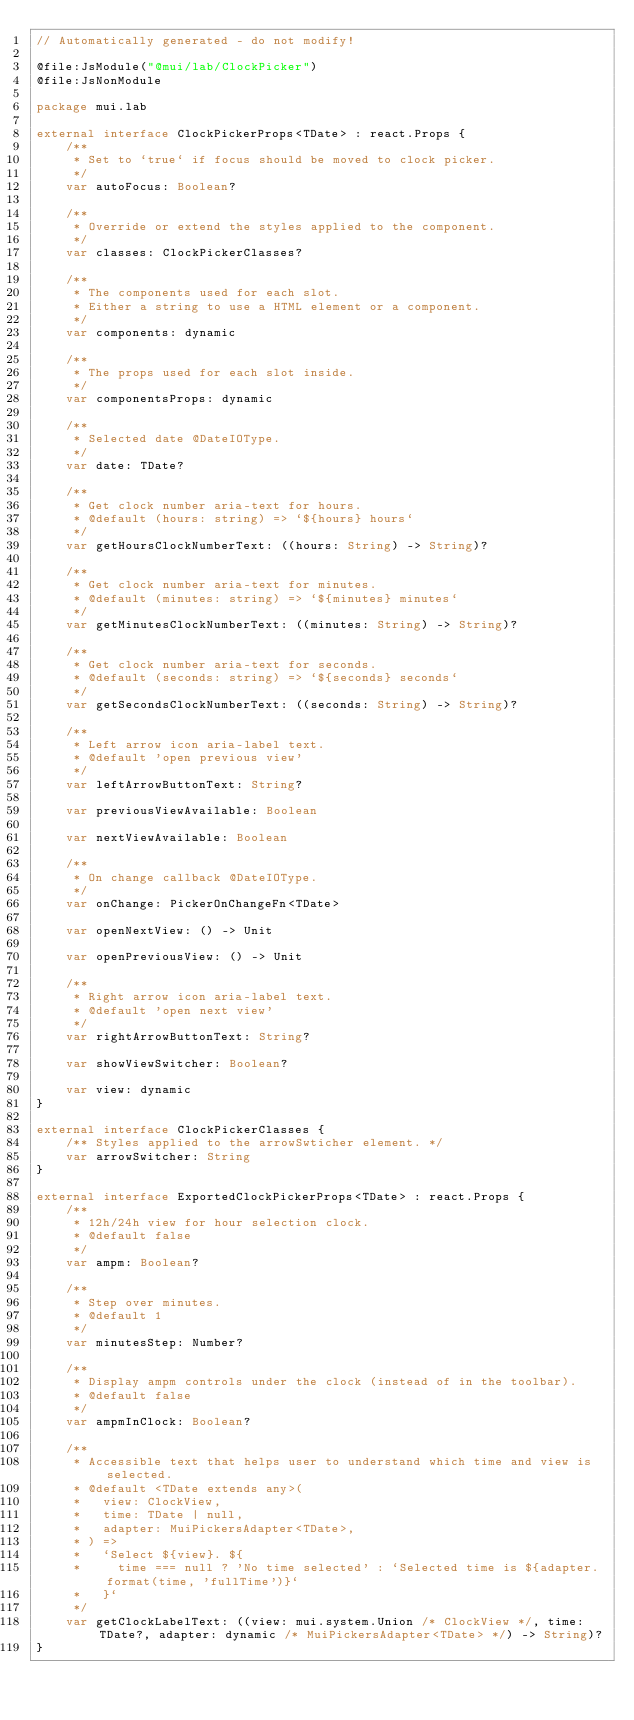<code> <loc_0><loc_0><loc_500><loc_500><_Kotlin_>// Automatically generated - do not modify!

@file:JsModule("@mui/lab/ClockPicker")
@file:JsNonModule

package mui.lab

external interface ClockPickerProps<TDate> : react.Props {
    /**
     * Set to `true` if focus should be moved to clock picker.
     */
    var autoFocus: Boolean?

    /**
     * Override or extend the styles applied to the component.
     */
    var classes: ClockPickerClasses?

    /**
     * The components used for each slot.
     * Either a string to use a HTML element or a component.
     */
    var components: dynamic

    /**
     * The props used for each slot inside.
     */
    var componentsProps: dynamic

    /**
     * Selected date @DateIOType.
     */
    var date: TDate?

    /**
     * Get clock number aria-text for hours.
     * @default (hours: string) => `${hours} hours`
     */
    var getHoursClockNumberText: ((hours: String) -> String)?

    /**
     * Get clock number aria-text for minutes.
     * @default (minutes: string) => `${minutes} minutes`
     */
    var getMinutesClockNumberText: ((minutes: String) -> String)?

    /**
     * Get clock number aria-text for seconds.
     * @default (seconds: string) => `${seconds} seconds`
     */
    var getSecondsClockNumberText: ((seconds: String) -> String)?

    /**
     * Left arrow icon aria-label text.
     * @default 'open previous view'
     */
    var leftArrowButtonText: String?

    var previousViewAvailable: Boolean

    var nextViewAvailable: Boolean

    /**
     * On change callback @DateIOType.
     */
    var onChange: PickerOnChangeFn<TDate>

    var openNextView: () -> Unit

    var openPreviousView: () -> Unit

    /**
     * Right arrow icon aria-label text.
     * @default 'open next view'
     */
    var rightArrowButtonText: String?

    var showViewSwitcher: Boolean?

    var view: dynamic
}

external interface ClockPickerClasses {
    /** Styles applied to the arrowSwticher element. */
    var arrowSwitcher: String
}

external interface ExportedClockPickerProps<TDate> : react.Props {
    /**
     * 12h/24h view for hour selection clock.
     * @default false
     */
    var ampm: Boolean?

    /**
     * Step over minutes.
     * @default 1
     */
    var minutesStep: Number?

    /**
     * Display ampm controls under the clock (instead of in the toolbar).
     * @default false
     */
    var ampmInClock: Boolean?

    /**
     * Accessible text that helps user to understand which time and view is selected.
     * @default <TDate extends any>(
     *   view: ClockView,
     *   time: TDate | null,
     *   adapter: MuiPickersAdapter<TDate>,
     * ) =>
     *   `Select ${view}. ${
     *     time === null ? 'No time selected' : `Selected time is ${adapter.format(time, 'fullTime')}`
     *   }`
     */
    var getClockLabelText: ((view: mui.system.Union /* ClockView */, time: TDate?, adapter: dynamic /* MuiPickersAdapter<TDate> */) -> String)?
}
</code> 